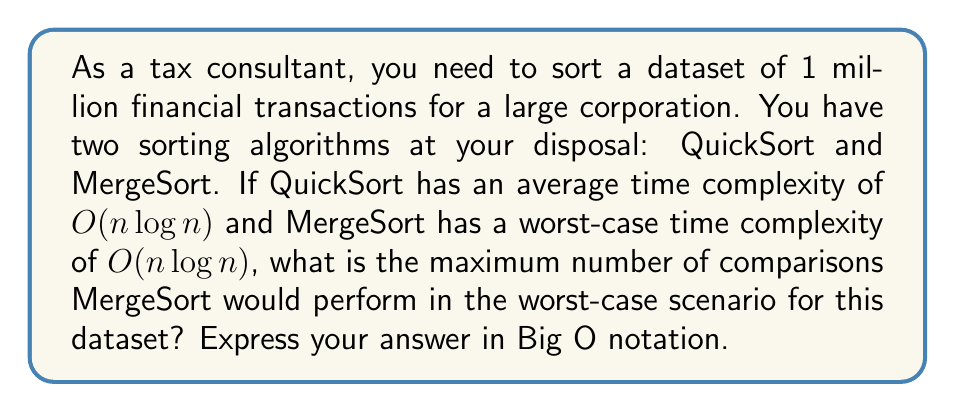Provide a solution to this math problem. To solve this problem, we need to follow these steps:

1. Identify the input size:
   $n = 1,000,000$ (1 million financial transactions)

2. Recall the worst-case time complexity of MergeSort:
   $O(n \log n)$

3. Calculate $\log n$:
   $\log_2 1,000,000 \approx 19.93$ (rounded to 2 decimal places)

4. The exact number of comparisons in the worst case for MergeSort is bounded by:
   $n \log_2 n - n + 1$

5. Substitute the values:
   $1,000,000 \cdot 19.93 - 1,000,000 + 1 \approx 18,930,001$

6. Express the result in Big O notation:
   Since we're dealing with the worst-case scenario and we're asked for the maximum number of comparisons, we keep the $n \log n$ term and drop the lower-order terms.

The maximum number of comparisons in the worst-case scenario for MergeSort on this dataset would be $O(n \log n)$.

It's worth noting that while QuickSort has the same average-case time complexity, its worst-case time complexity is $O(n^2)$. In practice, for large datasets like this, MergeSort might be preferred due to its guaranteed $O(n \log n)$ performance in all cases.
Answer: $O(n \log n)$ 